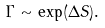<formula> <loc_0><loc_0><loc_500><loc_500>\Gamma \sim \exp ( \Delta S ) .</formula> 